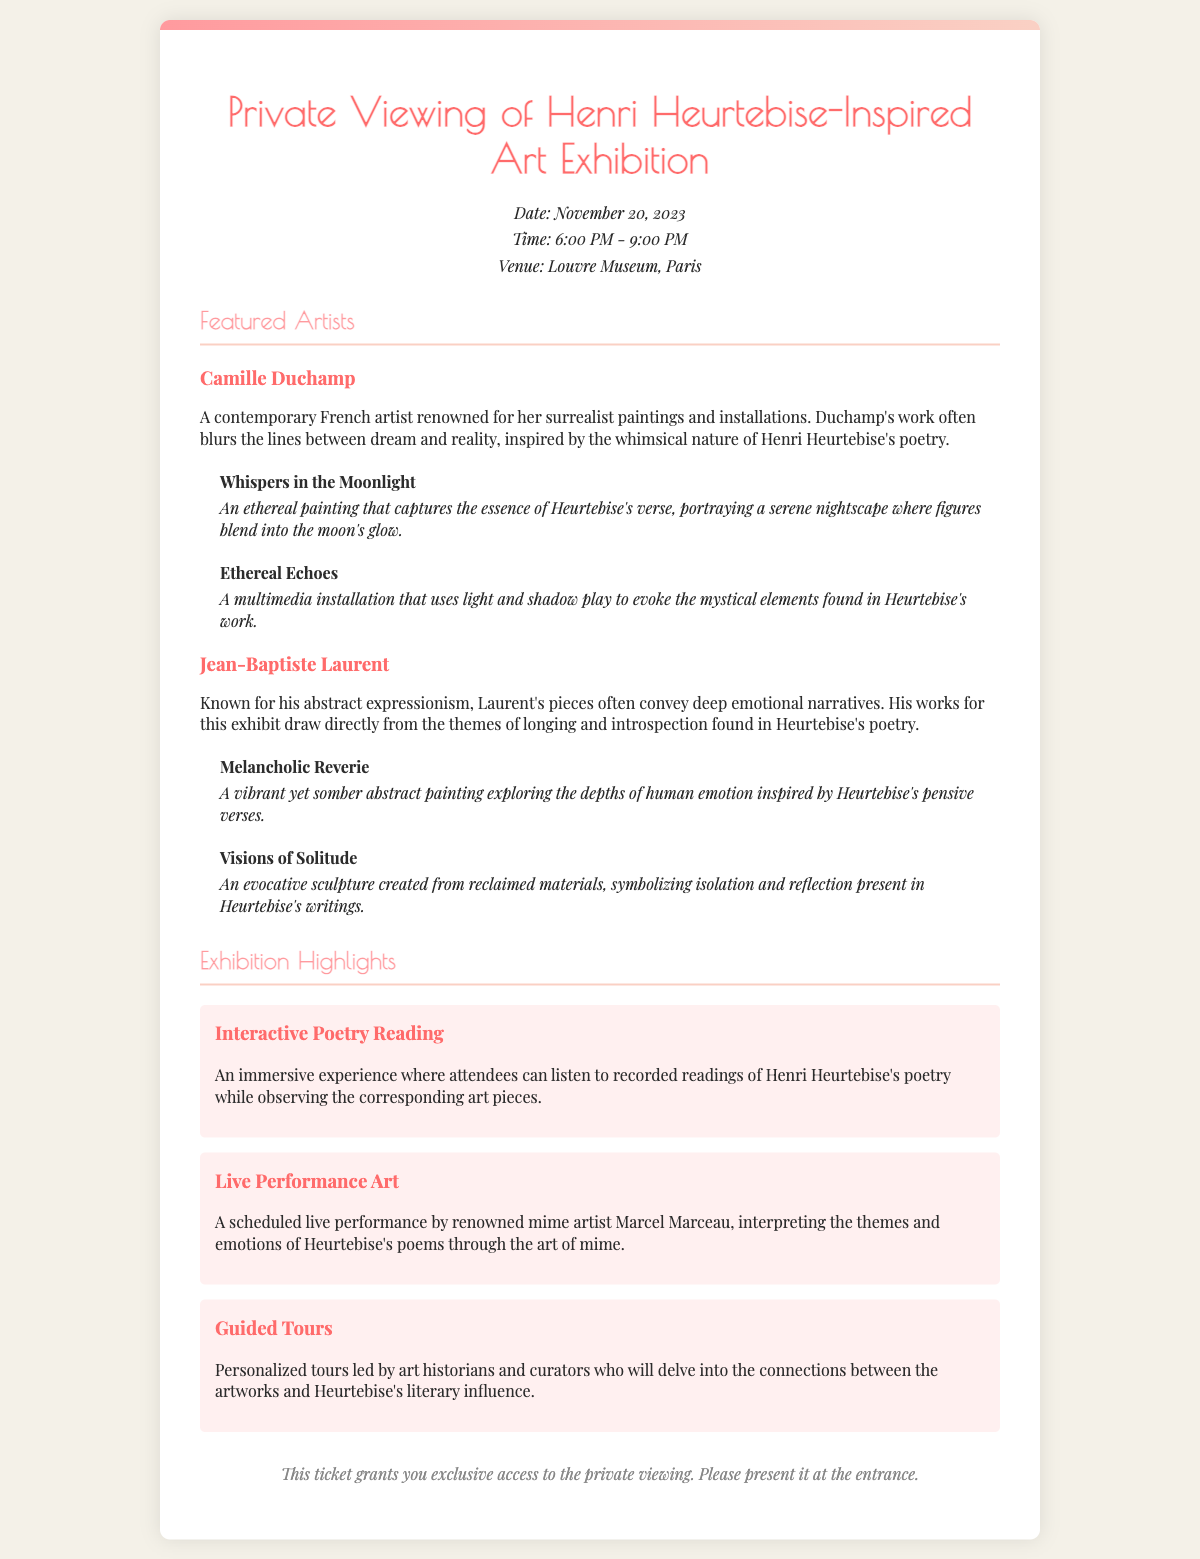What is the date of the exhibition? The date of the exhibition is specified in the ticket information section of the document.
Answer: November 20, 2023 What time does the exhibition start? The time of the exhibition is mentioned in the ticket information section.
Answer: 6:00 PM Which museum is hosting the exhibition? The venue where the exhibition is taking place is provided in the document.
Answer: Louvre Museum Who is featured as a contemporary artist? This information is found in the section describing featured artists in the document.
Answer: Camille Duchamp What is the title of Jean-Baptiste Laurent's abstract painting? The title of Laurent's artwork is listed under his description.
Answer: Melancholic Reverie What interactive experience is provided during the exhibition? This is mentioned in the highlights section describing exhibition features.
Answer: Interactive Poetry Reading Who will perform live at the exhibition? The name of the person performing live is mentioned in the highlights section.
Answer: Marcel Marceau How will attendees learn about the artworks? This information is provided in the highlights section about personalized experiences at the exhibition.
Answer: Guided Tours What is the nature of Camille Duchamp's artwork "Whispers in the Moonlight"? The document describes the artwork's themes and characteristics.
Answer: Ethereal painting 